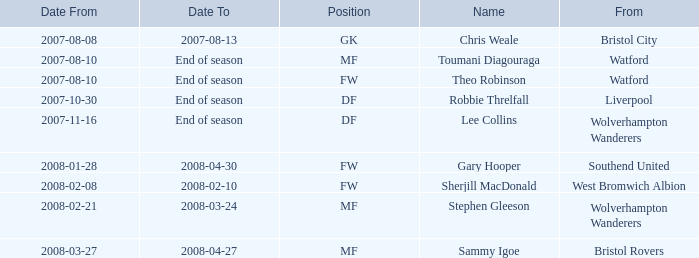On which date did toumani diagouraga, holding the role of mf, begin? 2007-08-10. 